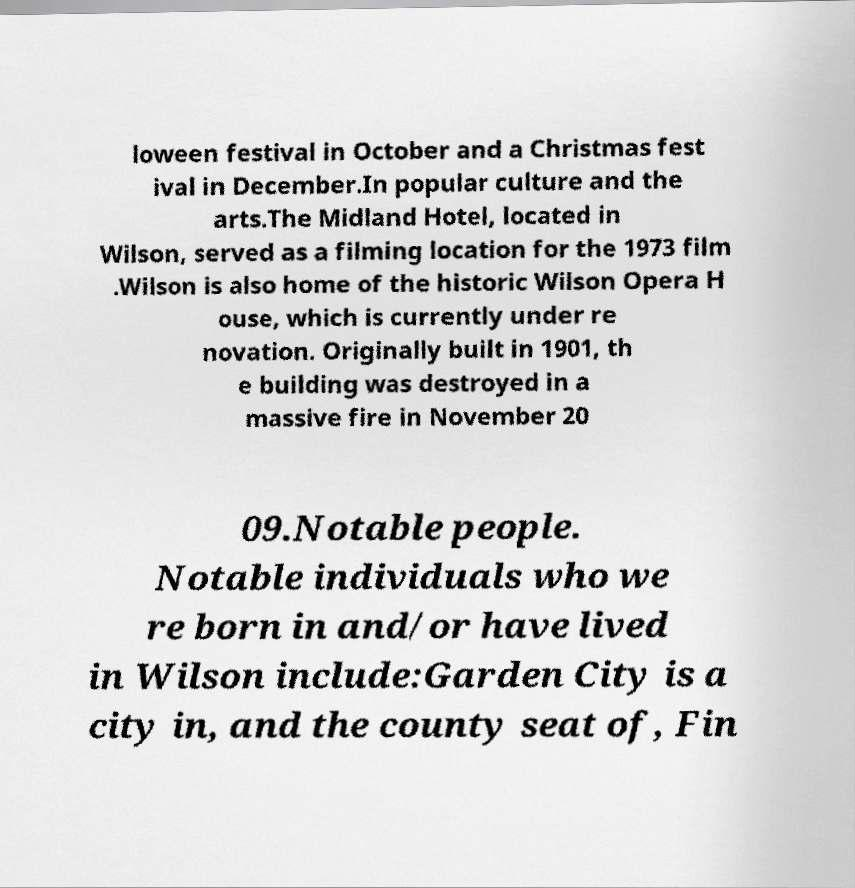Could you assist in decoding the text presented in this image and type it out clearly? loween festival in October and a Christmas fest ival in December.In popular culture and the arts.The Midland Hotel, located in Wilson, served as a filming location for the 1973 film .Wilson is also home of the historic Wilson Opera H ouse, which is currently under re novation. Originally built in 1901, th e building was destroyed in a massive fire in November 20 09.Notable people. Notable individuals who we re born in and/or have lived in Wilson include:Garden City is a city in, and the county seat of, Fin 